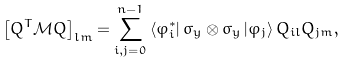<formula> <loc_0><loc_0><loc_500><loc_500>\left [ Q ^ { T } \mathcal { M } Q \right ] _ { l m } = \sum _ { i , j = 0 } ^ { n - 1 } \left \langle \varphi _ { i } ^ { \ast } \right | \sigma _ { y } \otimes \sigma _ { y } \left | \varphi _ { j } \right \rangle Q _ { i l } Q _ { j m } ,</formula> 